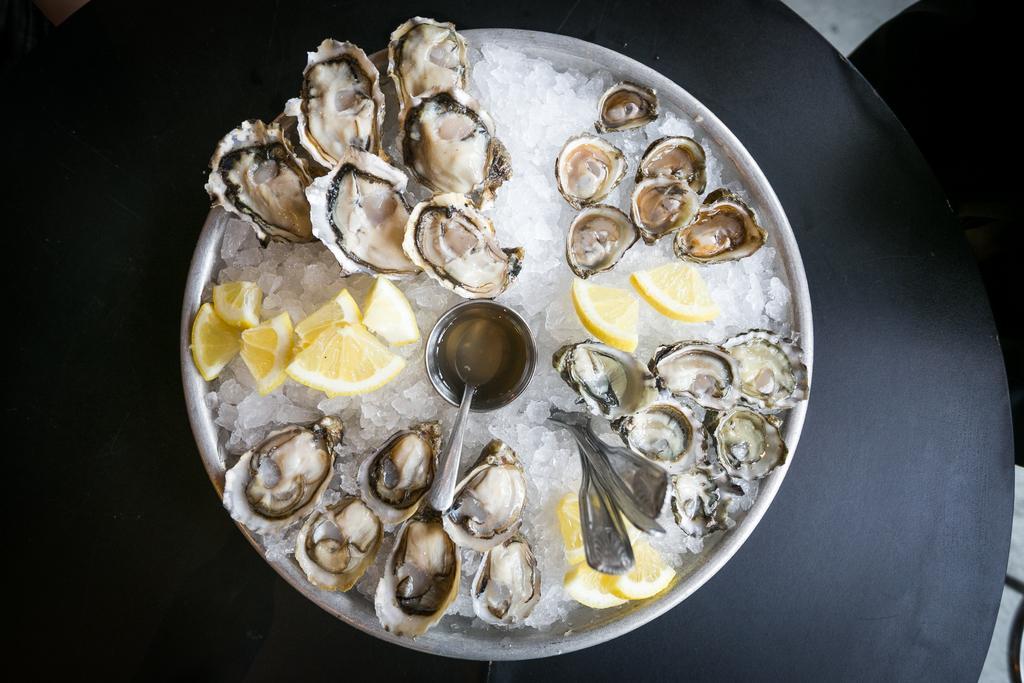Describe this image in one or two sentences. In this image we can see sea food, bowl, spoon, and a plate on a black color surface. 